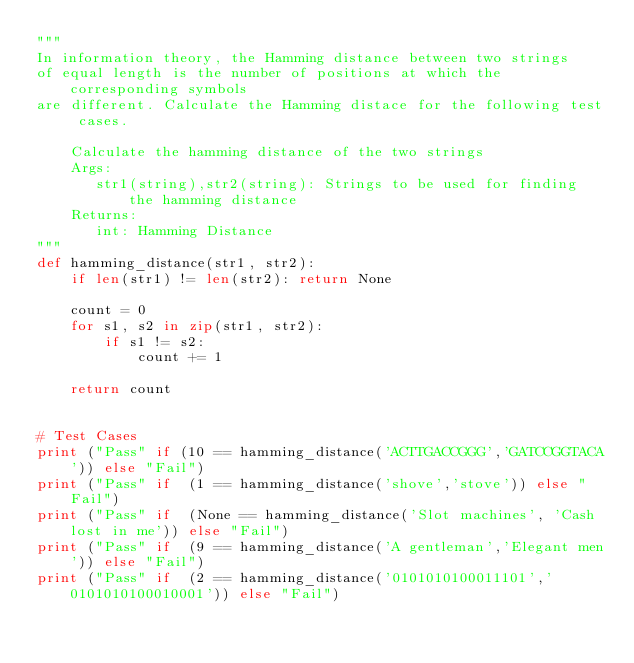<code> <loc_0><loc_0><loc_500><loc_500><_Python_>"""
In information theory, the Hamming distance between two strings
of equal length is the number of positions at which the corresponding symbols
are different. Calculate the Hamming distace for the following test cases.

    Calculate the hamming distance of the two strings
    Args:
       str1(string),str2(string): Strings to be used for finding the hamming distance
    Returns:
       int: Hamming Distance
"""
def hamming_distance(str1, str2):
    if len(str1) != len(str2): return None

    count = 0
    for s1, s2 in zip(str1, str2):
        if s1 != s2:
            count += 1

    return count


# Test Cases
print ("Pass" if (10 == hamming_distance('ACTTGACCGGG','GATCCGGTACA')) else "Fail")
print ("Pass" if  (1 == hamming_distance('shove','stove')) else "Fail")
print ("Pass" if  (None == hamming_distance('Slot machines', 'Cash lost in me')) else "Fail")
print ("Pass" if  (9 == hamming_distance('A gentleman','Elegant men')) else "Fail")
print ("Pass" if  (2 == hamming_distance('0101010100011101','0101010100010001')) else "Fail")
</code> 